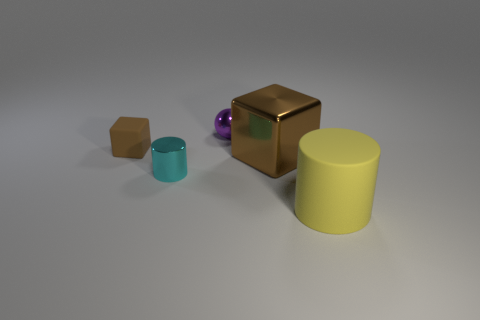What number of objects are shiny cubes or small red rubber cubes?
Give a very brief answer. 1. The matte object that is in front of the small cyan metallic object is what color?
Give a very brief answer. Yellow. Are there fewer tiny metallic cylinders that are on the left side of the big brown shiny block than big green matte spheres?
Keep it short and to the point. No. What size is the thing that is the same color as the big metal cube?
Offer a terse response. Small. Is there any other thing that has the same size as the yellow matte thing?
Your response must be concise. Yes. Is the material of the small brown cube the same as the big block?
Give a very brief answer. No. What number of objects are metallic things in front of the brown rubber thing or objects to the left of the large yellow object?
Offer a terse response. 4. Is there a matte cylinder of the same size as the metallic cube?
Offer a terse response. Yes. What color is the other thing that is the same shape as the large brown shiny object?
Ensure brevity in your answer.  Brown. Is there a large shiny cube that is behind the big thing that is behind the large matte cylinder?
Ensure brevity in your answer.  No. 